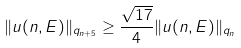<formula> <loc_0><loc_0><loc_500><loc_500>\| u ( n , E ) \| _ { q _ { n + 5 } } \geq \frac { \sqrt { 1 7 } } { 4 } \| u ( n , E ) \| _ { q _ { n } }</formula> 